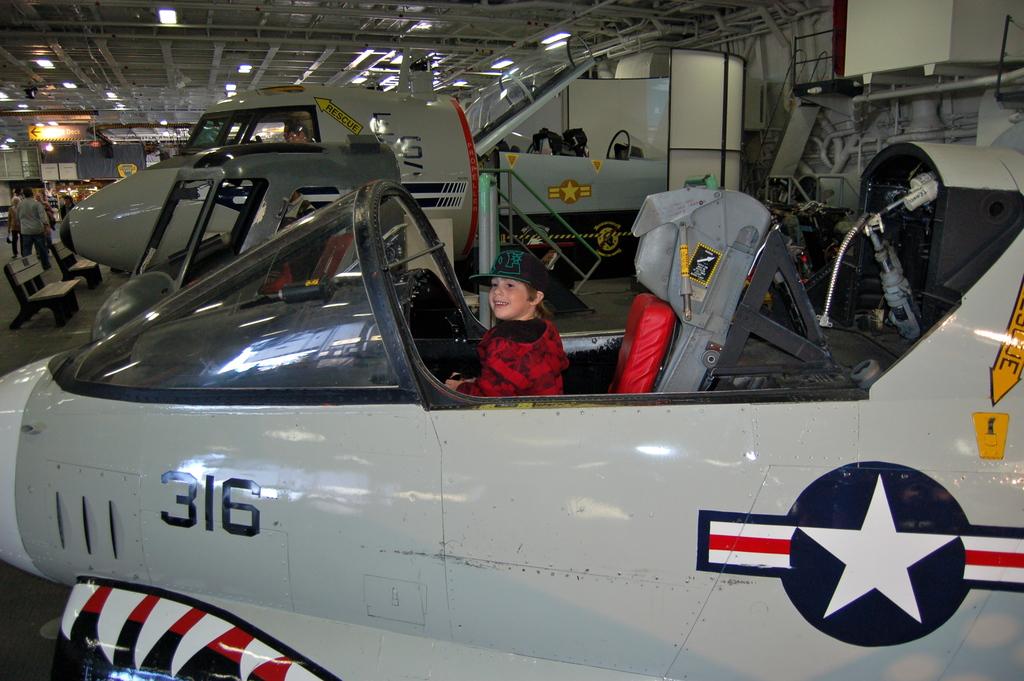Is that jet?
Provide a short and direct response. Answering does not require reading text in the image. How many person in the jet?
Your answer should be very brief. Answering does not require reading text in the image. 